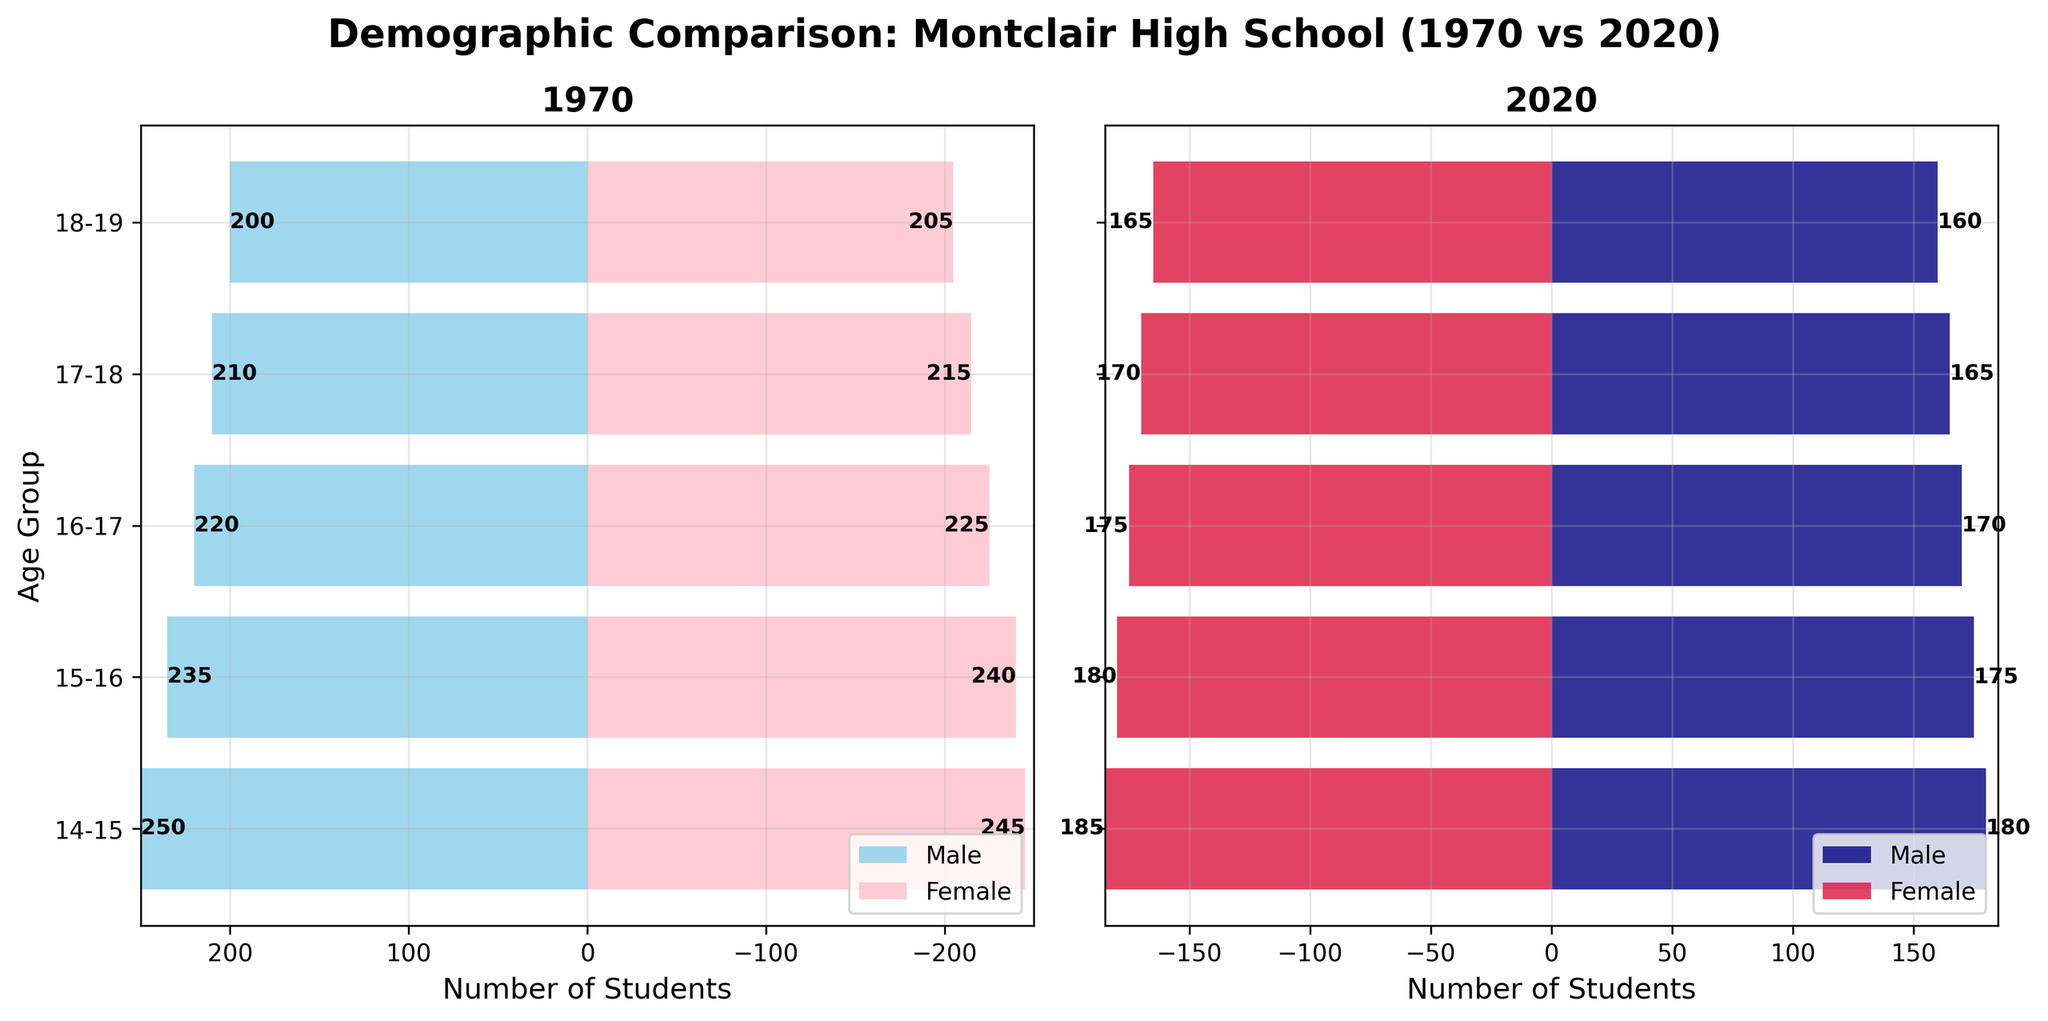Which year has more male students aged 15-16? In the 1970 section, the number of male students aged 15-16 is 235. In the 2020 section, it is 175. 235 is greater than 175.
Answer: 1970 Which age group had the highest number of female students in 1970? By comparing the values for female students in 1970 across all age groups, 15-16 and 16-17 have the highest values, which are 245 and 240 respectively.
Answer: 14-15 Is the number of male students aged 16-17 higher or lower in 2020 compared to 1970? In 1970, the number of male students aged 16-17 is 220. In 2020, it is 170. 220 is greater than 170, so it is lower in 2020.
Answer: Lower How does the number of female students aged 18-19 in 1970 compare to that in 2020? In 1970, the number of female students aged 18-19 is 205. In 2020, it is 165. 205 is greater than 165.
Answer: Higher in 1970 What's the difference in the total number of students aged 17-18 in 1970 between males and females? The number of male students aged 17-18 was 210 and female students were 215 in 1970. The difference is 215 - 210 = 5.
Answer: 5 What trend can be observed in the number of male students across age groups for 2020? Male student numbers steadily decrease as age increases: from 180 in 14-15 down to 160 in 18-19.
Answer: Decreasing How does the average number of female students aged 14-15 and 15-16 in 2020 compare to their average in 1970? In 2020, the numbers are 185 (14-15) and 180 (15-16). Average = (185 + 180)/2 = 182.5. In 1970, the numbers are 245 and 240. Average = (245 + 240)/2 = 242.5. Comparison: 242.5 (1970) > 182.5 (2020).
Answer: Higher in 1970 Identify the age group where the number of female students in 2020 is closest to the number of female students in 1970. Calculating the absolute differences for each age group gives 14-15: 245-185=60, 15-16: 240-180=60, 16-17: 225-175=50, 17-18: 215-170=45, 18-19: 205-165=40. The smallest difference is for age group 18-19.
Answer: 18-19 